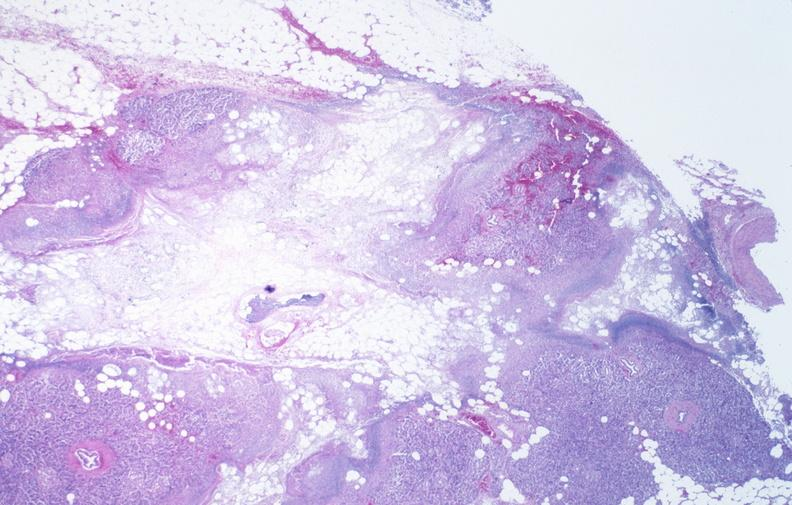what does this image show?
Answer the question using a single word or phrase. Pancreatic fat necrosis 